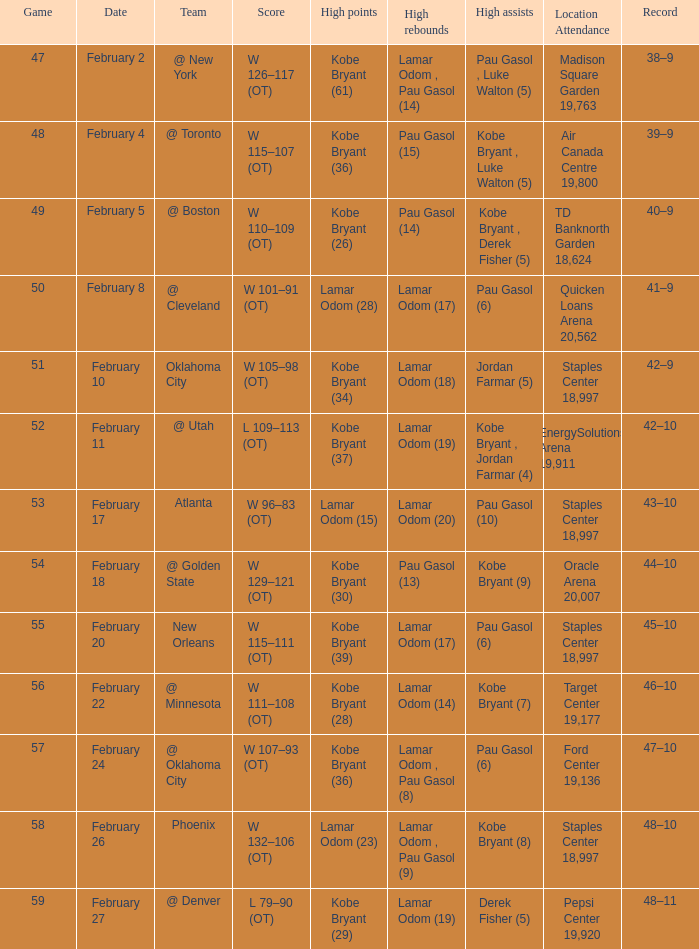Who had the most assists in the game against Atlanta? Pau Gasol (10). Could you parse the entire table as a dict? {'header': ['Game', 'Date', 'Team', 'Score', 'High points', 'High rebounds', 'High assists', 'Location Attendance', 'Record'], 'rows': [['47', 'February 2', '@ New York', 'W 126–117 (OT)', 'Kobe Bryant (61)', 'Lamar Odom , Pau Gasol (14)', 'Pau Gasol , Luke Walton (5)', 'Madison Square Garden 19,763', '38–9'], ['48', 'February 4', '@ Toronto', 'W 115–107 (OT)', 'Kobe Bryant (36)', 'Pau Gasol (15)', 'Kobe Bryant , Luke Walton (5)', 'Air Canada Centre 19,800', '39–9'], ['49', 'February 5', '@ Boston', 'W 110–109 (OT)', 'Kobe Bryant (26)', 'Pau Gasol (14)', 'Kobe Bryant , Derek Fisher (5)', 'TD Banknorth Garden 18,624', '40–9'], ['50', 'February 8', '@ Cleveland', 'W 101–91 (OT)', 'Lamar Odom (28)', 'Lamar Odom (17)', 'Pau Gasol (6)', 'Quicken Loans Arena 20,562', '41–9'], ['51', 'February 10', 'Oklahoma City', 'W 105–98 (OT)', 'Kobe Bryant (34)', 'Lamar Odom (18)', 'Jordan Farmar (5)', 'Staples Center 18,997', '42–9'], ['52', 'February 11', '@ Utah', 'L 109–113 (OT)', 'Kobe Bryant (37)', 'Lamar Odom (19)', 'Kobe Bryant , Jordan Farmar (4)', 'EnergySolutions Arena 19,911', '42–10'], ['53', 'February 17', 'Atlanta', 'W 96–83 (OT)', 'Lamar Odom (15)', 'Lamar Odom (20)', 'Pau Gasol (10)', 'Staples Center 18,997', '43–10'], ['54', 'February 18', '@ Golden State', 'W 129–121 (OT)', 'Kobe Bryant (30)', 'Pau Gasol (13)', 'Kobe Bryant (9)', 'Oracle Arena 20,007', '44–10'], ['55', 'February 20', 'New Orleans', 'W 115–111 (OT)', 'Kobe Bryant (39)', 'Lamar Odom (17)', 'Pau Gasol (6)', 'Staples Center 18,997', '45–10'], ['56', 'February 22', '@ Minnesota', 'W 111–108 (OT)', 'Kobe Bryant (28)', 'Lamar Odom (14)', 'Kobe Bryant (7)', 'Target Center 19,177', '46–10'], ['57', 'February 24', '@ Oklahoma City', 'W 107–93 (OT)', 'Kobe Bryant (36)', 'Lamar Odom , Pau Gasol (8)', 'Pau Gasol (6)', 'Ford Center 19,136', '47–10'], ['58', 'February 26', 'Phoenix', 'W 132–106 (OT)', 'Lamar Odom (23)', 'Lamar Odom , Pau Gasol (9)', 'Kobe Bryant (8)', 'Staples Center 18,997', '48–10'], ['59', 'February 27', '@ Denver', 'L 79–90 (OT)', 'Kobe Bryant (29)', 'Lamar Odom (19)', 'Derek Fisher (5)', 'Pepsi Center 19,920', '48–11']]} 